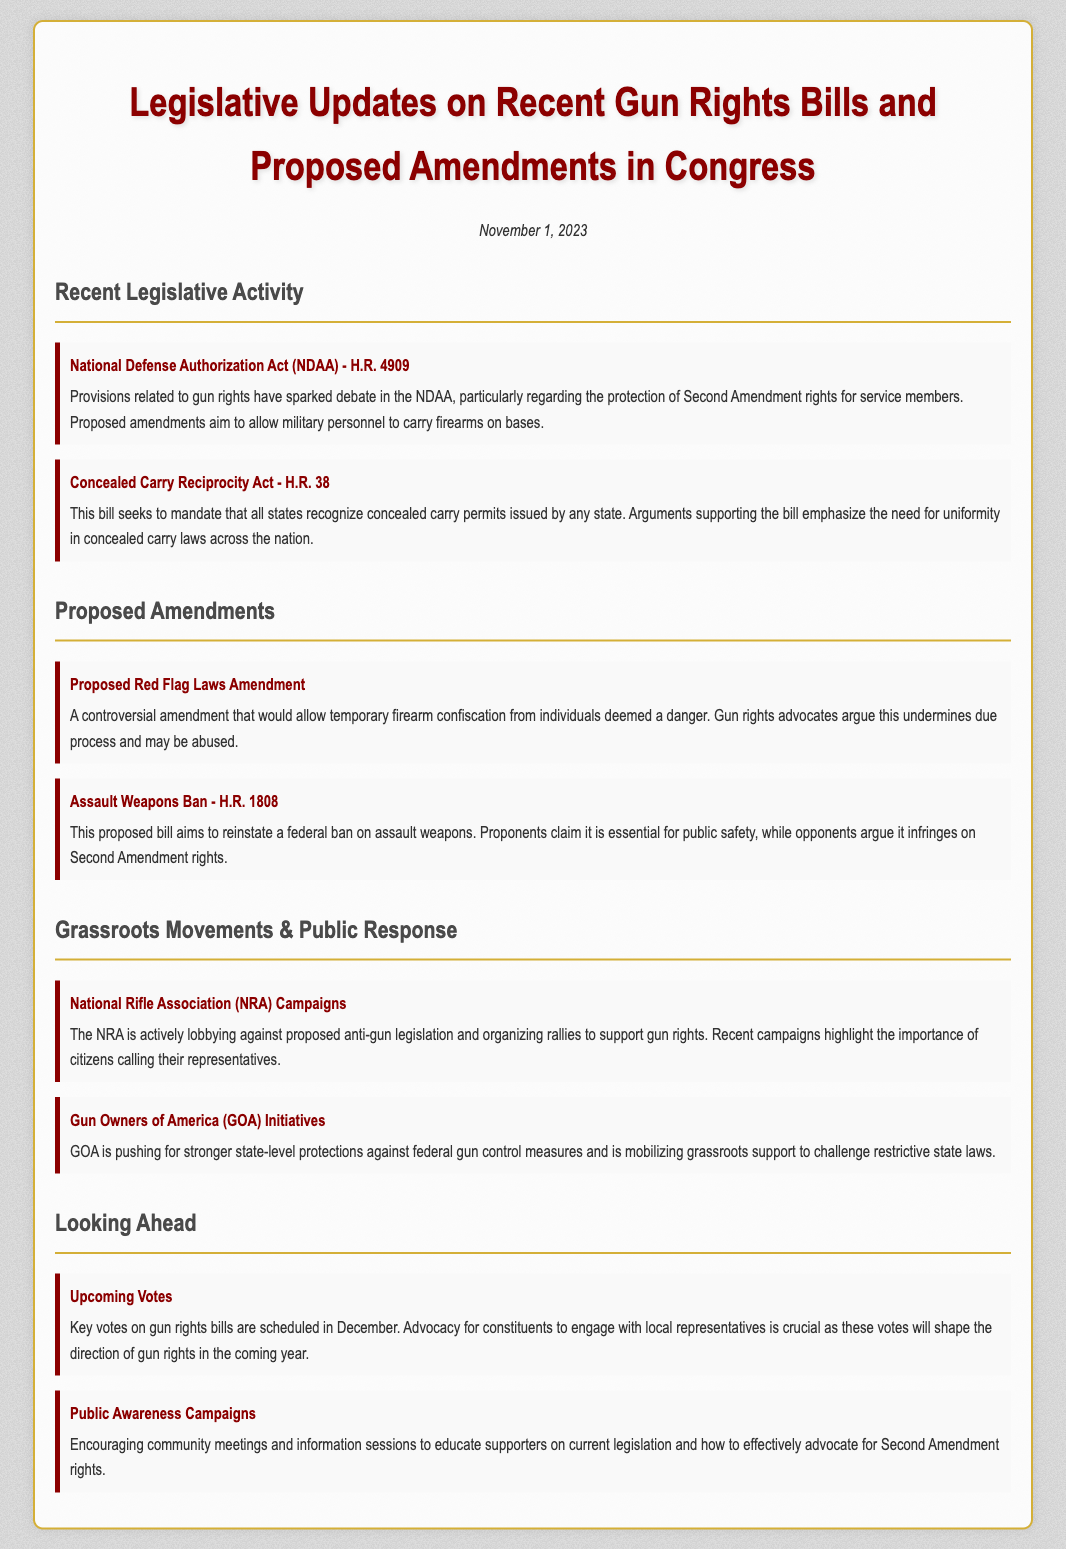What is the title of the document? The title of the document is found prominently at the top, clearly stated.
Answer: Legislative Updates on Recent Gun Rights Bills and Proposed Amendments in Congress What is the date of the document? The date is mentioned in the document below the title.
Answer: November 1, 2023 What is the bill number associated with the National Defense Authorization Act? The bill number is specified in the section discussing recent legislative activity.
Answer: H.R. 4909 What does the Concealed Carry Reciprocity Act seek to mandate? The goals of the act are outlined, indicating what it aims to achieve regarding state laws.
Answer: Recognition of concealed carry permits What does the Proposed Red Flag Laws Amendment allow? This amendment's description clarifies its intended action regarding firearms.
Answer: Temporary firearm confiscation What is a key focus of the NRA campaigns? The description highlights the main activity of the NRA concerning gun rights.
Answer: Lobbying against proposed anti-gun legislation When are key votes on gun rights bills scheduled? The document specifies a time frame for important legislative actions.
Answer: December What organization is pushing for state-level protections against federal gun control? The document identifies a specific organization advocating for state-level actions.
Answer: Gun Owners of America What is the purpose of upcoming public awareness campaigns? The document explains the goal of the campaigns being organized.
Answer: Educate supporters on current legislation 